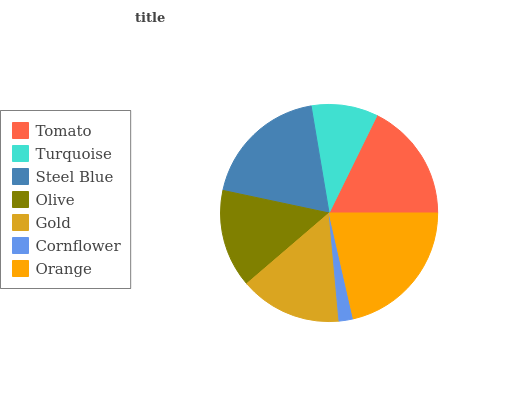Is Cornflower the minimum?
Answer yes or no. Yes. Is Orange the maximum?
Answer yes or no. Yes. Is Turquoise the minimum?
Answer yes or no. No. Is Turquoise the maximum?
Answer yes or no. No. Is Tomato greater than Turquoise?
Answer yes or no. Yes. Is Turquoise less than Tomato?
Answer yes or no. Yes. Is Turquoise greater than Tomato?
Answer yes or no. No. Is Tomato less than Turquoise?
Answer yes or no. No. Is Gold the high median?
Answer yes or no. Yes. Is Gold the low median?
Answer yes or no. Yes. Is Turquoise the high median?
Answer yes or no. No. Is Tomato the low median?
Answer yes or no. No. 